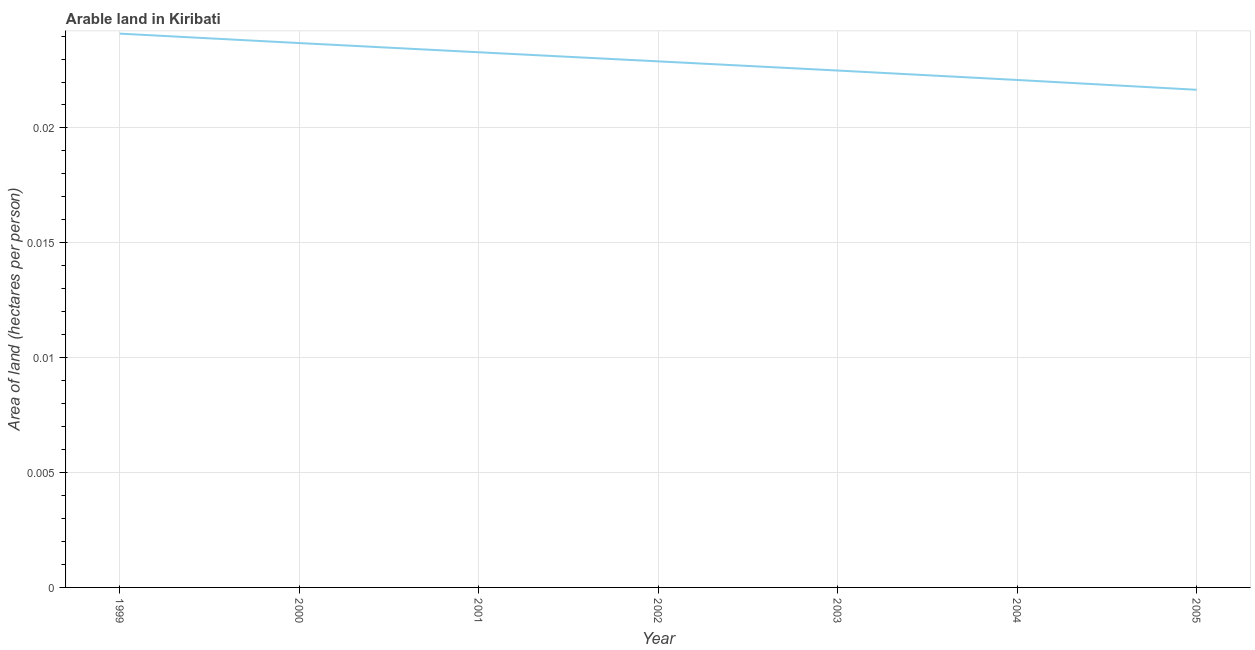What is the area of arable land in 2003?
Provide a short and direct response. 0.02. Across all years, what is the maximum area of arable land?
Keep it short and to the point. 0.02. Across all years, what is the minimum area of arable land?
Provide a short and direct response. 0.02. What is the sum of the area of arable land?
Provide a short and direct response. 0.16. What is the difference between the area of arable land in 2000 and 2004?
Offer a terse response. 0. What is the average area of arable land per year?
Your answer should be compact. 0.02. What is the median area of arable land?
Offer a very short reply. 0.02. Do a majority of the years between 2003 and 2000 (inclusive) have area of arable land greater than 0.011 hectares per person?
Offer a very short reply. Yes. What is the ratio of the area of arable land in 2000 to that in 2001?
Your response must be concise. 1.02. Is the area of arable land in 1999 less than that in 2005?
Give a very brief answer. No. Is the difference between the area of arable land in 2000 and 2004 greater than the difference between any two years?
Give a very brief answer. No. What is the difference between the highest and the second highest area of arable land?
Give a very brief answer. 0. Is the sum of the area of arable land in 2002 and 2003 greater than the maximum area of arable land across all years?
Give a very brief answer. Yes. What is the difference between the highest and the lowest area of arable land?
Ensure brevity in your answer.  0. In how many years, is the area of arable land greater than the average area of arable land taken over all years?
Your answer should be very brief. 4. How many lines are there?
Your answer should be compact. 1. How many years are there in the graph?
Your answer should be compact. 7. What is the difference between two consecutive major ticks on the Y-axis?
Ensure brevity in your answer.  0.01. Does the graph contain any zero values?
Your answer should be compact. No. Does the graph contain grids?
Keep it short and to the point. Yes. What is the title of the graph?
Give a very brief answer. Arable land in Kiribati. What is the label or title of the Y-axis?
Make the answer very short. Area of land (hectares per person). What is the Area of land (hectares per person) of 1999?
Keep it short and to the point. 0.02. What is the Area of land (hectares per person) in 2000?
Provide a short and direct response. 0.02. What is the Area of land (hectares per person) of 2001?
Your answer should be very brief. 0.02. What is the Area of land (hectares per person) of 2002?
Provide a succinct answer. 0.02. What is the Area of land (hectares per person) in 2003?
Your answer should be compact. 0.02. What is the Area of land (hectares per person) of 2004?
Your answer should be very brief. 0.02. What is the Area of land (hectares per person) of 2005?
Keep it short and to the point. 0.02. What is the difference between the Area of land (hectares per person) in 1999 and 2000?
Give a very brief answer. 0. What is the difference between the Area of land (hectares per person) in 1999 and 2001?
Make the answer very short. 0. What is the difference between the Area of land (hectares per person) in 1999 and 2002?
Your answer should be compact. 0. What is the difference between the Area of land (hectares per person) in 1999 and 2003?
Make the answer very short. 0. What is the difference between the Area of land (hectares per person) in 1999 and 2004?
Provide a succinct answer. 0. What is the difference between the Area of land (hectares per person) in 1999 and 2005?
Offer a terse response. 0. What is the difference between the Area of land (hectares per person) in 2000 and 2002?
Give a very brief answer. 0. What is the difference between the Area of land (hectares per person) in 2000 and 2003?
Offer a very short reply. 0. What is the difference between the Area of land (hectares per person) in 2000 and 2004?
Ensure brevity in your answer.  0. What is the difference between the Area of land (hectares per person) in 2000 and 2005?
Offer a very short reply. 0. What is the difference between the Area of land (hectares per person) in 2001 and 2003?
Your answer should be compact. 0. What is the difference between the Area of land (hectares per person) in 2001 and 2004?
Give a very brief answer. 0. What is the difference between the Area of land (hectares per person) in 2001 and 2005?
Ensure brevity in your answer.  0. What is the difference between the Area of land (hectares per person) in 2002 and 2004?
Offer a very short reply. 0. What is the difference between the Area of land (hectares per person) in 2002 and 2005?
Give a very brief answer. 0. What is the difference between the Area of land (hectares per person) in 2003 and 2004?
Your answer should be compact. 0. What is the difference between the Area of land (hectares per person) in 2003 and 2005?
Your answer should be compact. 0. What is the difference between the Area of land (hectares per person) in 2004 and 2005?
Give a very brief answer. 0. What is the ratio of the Area of land (hectares per person) in 1999 to that in 2001?
Your answer should be very brief. 1.03. What is the ratio of the Area of land (hectares per person) in 1999 to that in 2002?
Offer a very short reply. 1.05. What is the ratio of the Area of land (hectares per person) in 1999 to that in 2003?
Ensure brevity in your answer.  1.07. What is the ratio of the Area of land (hectares per person) in 1999 to that in 2004?
Provide a short and direct response. 1.09. What is the ratio of the Area of land (hectares per person) in 1999 to that in 2005?
Ensure brevity in your answer.  1.11. What is the ratio of the Area of land (hectares per person) in 2000 to that in 2002?
Your answer should be very brief. 1.03. What is the ratio of the Area of land (hectares per person) in 2000 to that in 2003?
Keep it short and to the point. 1.05. What is the ratio of the Area of land (hectares per person) in 2000 to that in 2004?
Your answer should be compact. 1.07. What is the ratio of the Area of land (hectares per person) in 2000 to that in 2005?
Ensure brevity in your answer.  1.09. What is the ratio of the Area of land (hectares per person) in 2001 to that in 2003?
Keep it short and to the point. 1.03. What is the ratio of the Area of land (hectares per person) in 2001 to that in 2004?
Ensure brevity in your answer.  1.05. What is the ratio of the Area of land (hectares per person) in 2001 to that in 2005?
Provide a succinct answer. 1.07. What is the ratio of the Area of land (hectares per person) in 2002 to that in 2004?
Make the answer very short. 1.04. What is the ratio of the Area of land (hectares per person) in 2002 to that in 2005?
Your answer should be very brief. 1.06. What is the ratio of the Area of land (hectares per person) in 2003 to that in 2005?
Your answer should be compact. 1.04. 